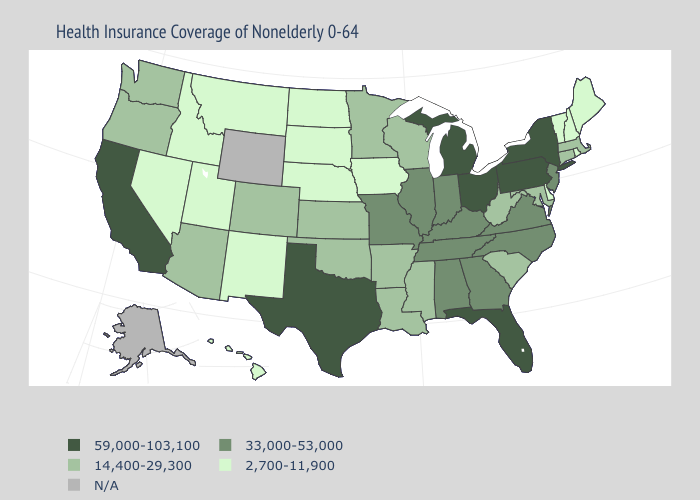What is the value of North Carolina?
Quick response, please. 33,000-53,000. What is the value of Florida?
Write a very short answer. 59,000-103,100. Among the states that border Oklahoma , which have the lowest value?
Keep it brief. New Mexico. Does Nebraska have the lowest value in the MidWest?
Give a very brief answer. Yes. What is the lowest value in states that border Montana?
Concise answer only. 2,700-11,900. Among the states that border Idaho , does Washington have the lowest value?
Quick response, please. No. What is the value of California?
Concise answer only. 59,000-103,100. Name the states that have a value in the range 2,700-11,900?
Quick response, please. Delaware, Hawaii, Idaho, Iowa, Maine, Montana, Nebraska, Nevada, New Hampshire, New Mexico, North Dakota, Rhode Island, South Dakota, Utah, Vermont. Is the legend a continuous bar?
Answer briefly. No. What is the value of Ohio?
Keep it brief. 59,000-103,100. Which states have the highest value in the USA?
Answer briefly. California, Florida, Michigan, New York, Ohio, Pennsylvania, Texas. Which states have the lowest value in the West?
Short answer required. Hawaii, Idaho, Montana, Nevada, New Mexico, Utah. What is the highest value in the USA?
Give a very brief answer. 59,000-103,100. 